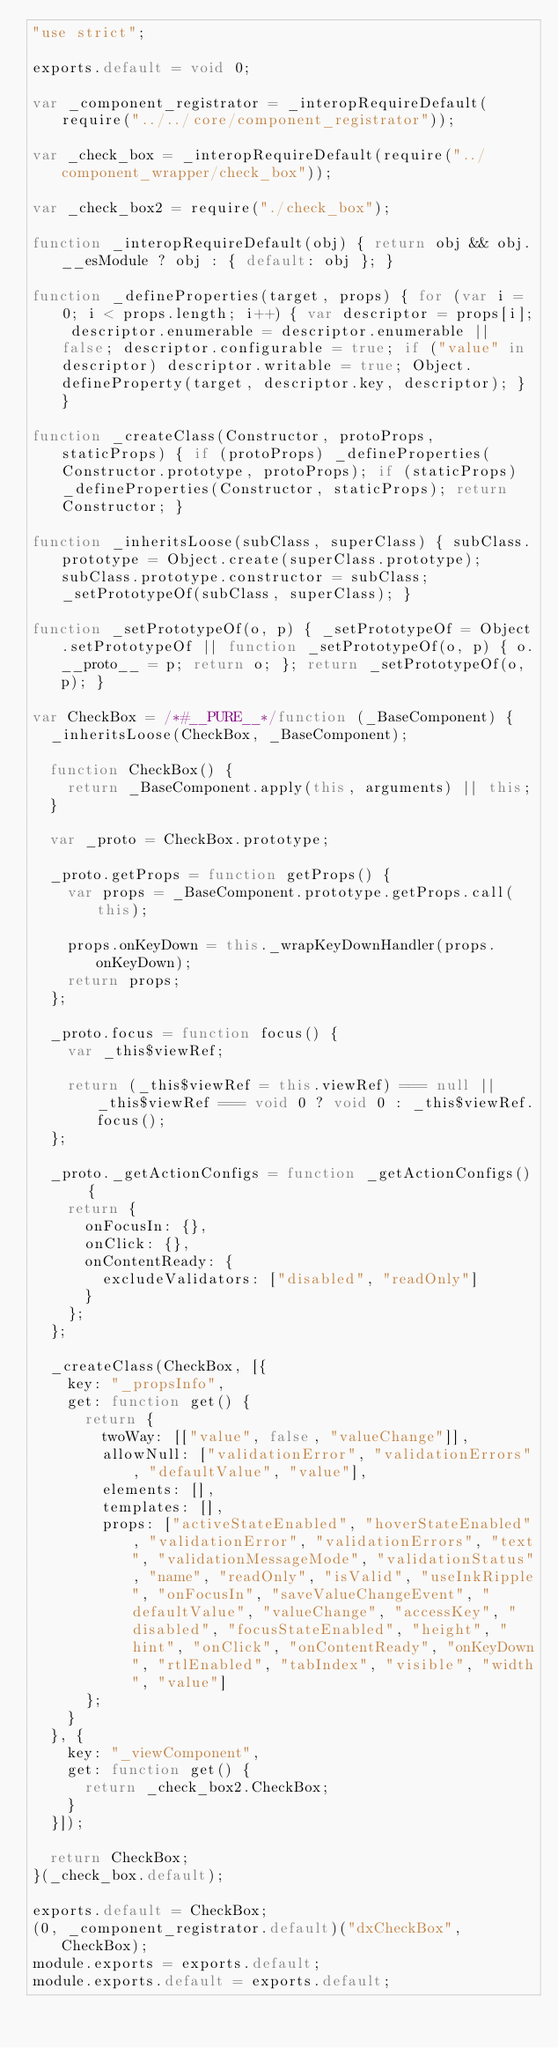<code> <loc_0><loc_0><loc_500><loc_500><_JavaScript_>"use strict";

exports.default = void 0;

var _component_registrator = _interopRequireDefault(require("../../core/component_registrator"));

var _check_box = _interopRequireDefault(require("../component_wrapper/check_box"));

var _check_box2 = require("./check_box");

function _interopRequireDefault(obj) { return obj && obj.__esModule ? obj : { default: obj }; }

function _defineProperties(target, props) { for (var i = 0; i < props.length; i++) { var descriptor = props[i]; descriptor.enumerable = descriptor.enumerable || false; descriptor.configurable = true; if ("value" in descriptor) descriptor.writable = true; Object.defineProperty(target, descriptor.key, descriptor); } }

function _createClass(Constructor, protoProps, staticProps) { if (protoProps) _defineProperties(Constructor.prototype, protoProps); if (staticProps) _defineProperties(Constructor, staticProps); return Constructor; }

function _inheritsLoose(subClass, superClass) { subClass.prototype = Object.create(superClass.prototype); subClass.prototype.constructor = subClass; _setPrototypeOf(subClass, superClass); }

function _setPrototypeOf(o, p) { _setPrototypeOf = Object.setPrototypeOf || function _setPrototypeOf(o, p) { o.__proto__ = p; return o; }; return _setPrototypeOf(o, p); }

var CheckBox = /*#__PURE__*/function (_BaseComponent) {
  _inheritsLoose(CheckBox, _BaseComponent);

  function CheckBox() {
    return _BaseComponent.apply(this, arguments) || this;
  }

  var _proto = CheckBox.prototype;

  _proto.getProps = function getProps() {
    var props = _BaseComponent.prototype.getProps.call(this);

    props.onKeyDown = this._wrapKeyDownHandler(props.onKeyDown);
    return props;
  };

  _proto.focus = function focus() {
    var _this$viewRef;

    return (_this$viewRef = this.viewRef) === null || _this$viewRef === void 0 ? void 0 : _this$viewRef.focus();
  };

  _proto._getActionConfigs = function _getActionConfigs() {
    return {
      onFocusIn: {},
      onClick: {},
      onContentReady: {
        excludeValidators: ["disabled", "readOnly"]
      }
    };
  };

  _createClass(CheckBox, [{
    key: "_propsInfo",
    get: function get() {
      return {
        twoWay: [["value", false, "valueChange"]],
        allowNull: ["validationError", "validationErrors", "defaultValue", "value"],
        elements: [],
        templates: [],
        props: ["activeStateEnabled", "hoverStateEnabled", "validationError", "validationErrors", "text", "validationMessageMode", "validationStatus", "name", "readOnly", "isValid", "useInkRipple", "onFocusIn", "saveValueChangeEvent", "defaultValue", "valueChange", "accessKey", "disabled", "focusStateEnabled", "height", "hint", "onClick", "onContentReady", "onKeyDown", "rtlEnabled", "tabIndex", "visible", "width", "value"]
      };
    }
  }, {
    key: "_viewComponent",
    get: function get() {
      return _check_box2.CheckBox;
    }
  }]);

  return CheckBox;
}(_check_box.default);

exports.default = CheckBox;
(0, _component_registrator.default)("dxCheckBox", CheckBox);
module.exports = exports.default;
module.exports.default = exports.default;</code> 